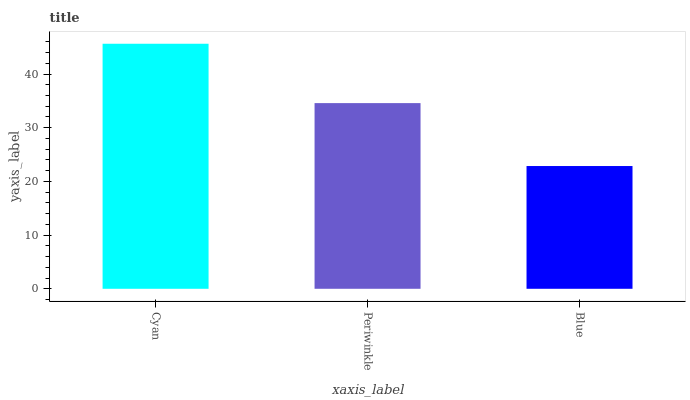Is Periwinkle the minimum?
Answer yes or no. No. Is Periwinkle the maximum?
Answer yes or no. No. Is Cyan greater than Periwinkle?
Answer yes or no. Yes. Is Periwinkle less than Cyan?
Answer yes or no. Yes. Is Periwinkle greater than Cyan?
Answer yes or no. No. Is Cyan less than Periwinkle?
Answer yes or no. No. Is Periwinkle the high median?
Answer yes or no. Yes. Is Periwinkle the low median?
Answer yes or no. Yes. Is Cyan the high median?
Answer yes or no. No. Is Blue the low median?
Answer yes or no. No. 